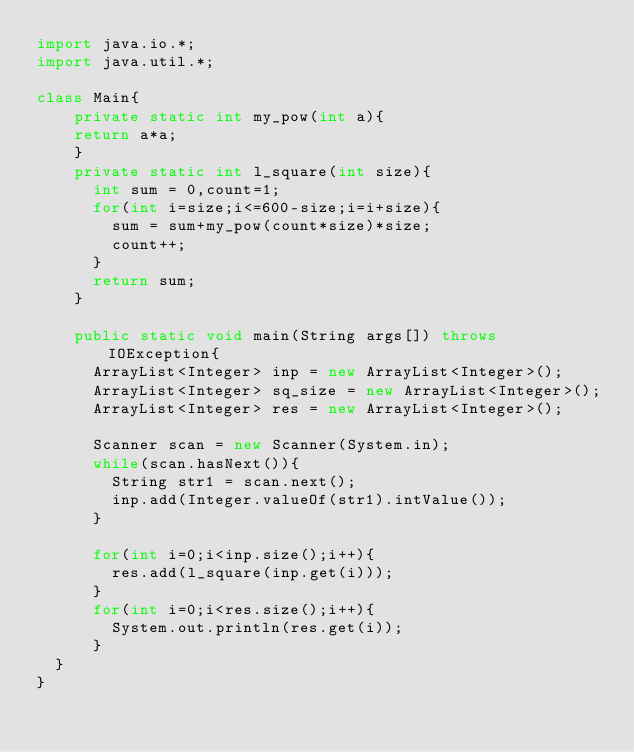Convert code to text. <code><loc_0><loc_0><loc_500><loc_500><_Java_>import java.io.*;
import java.util.*;

class Main{
		private static int my_pow(int a){
		return a*a;
		}
		private static int l_square(int size){
			int sum = 0,count=1;
			for(int i=size;i<=600-size;i=i+size){
				sum = sum+my_pow(count*size)*size;
				count++;
			}
			return sum;
		}
		
		public static void main(String args[]) throws IOException{
			ArrayList<Integer> inp = new ArrayList<Integer>();
			ArrayList<Integer> sq_size = new ArrayList<Integer>();
			ArrayList<Integer> res = new ArrayList<Integer>();
			
			Scanner scan = new Scanner(System.in);
			while(scan.hasNext()){
				String str1 = scan.next();
				inp.add(Integer.valueOf(str1).intValue());
			}

			for(int i=0;i<inp.size();i++){
				res.add(l_square(inp.get(i)));
			}
			for(int i=0;i<res.size();i++){
				System.out.println(res.get(i));
			}
	}
}</code> 